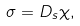Convert formula to latex. <formula><loc_0><loc_0><loc_500><loc_500>\sigma = D _ { s } \chi ,</formula> 